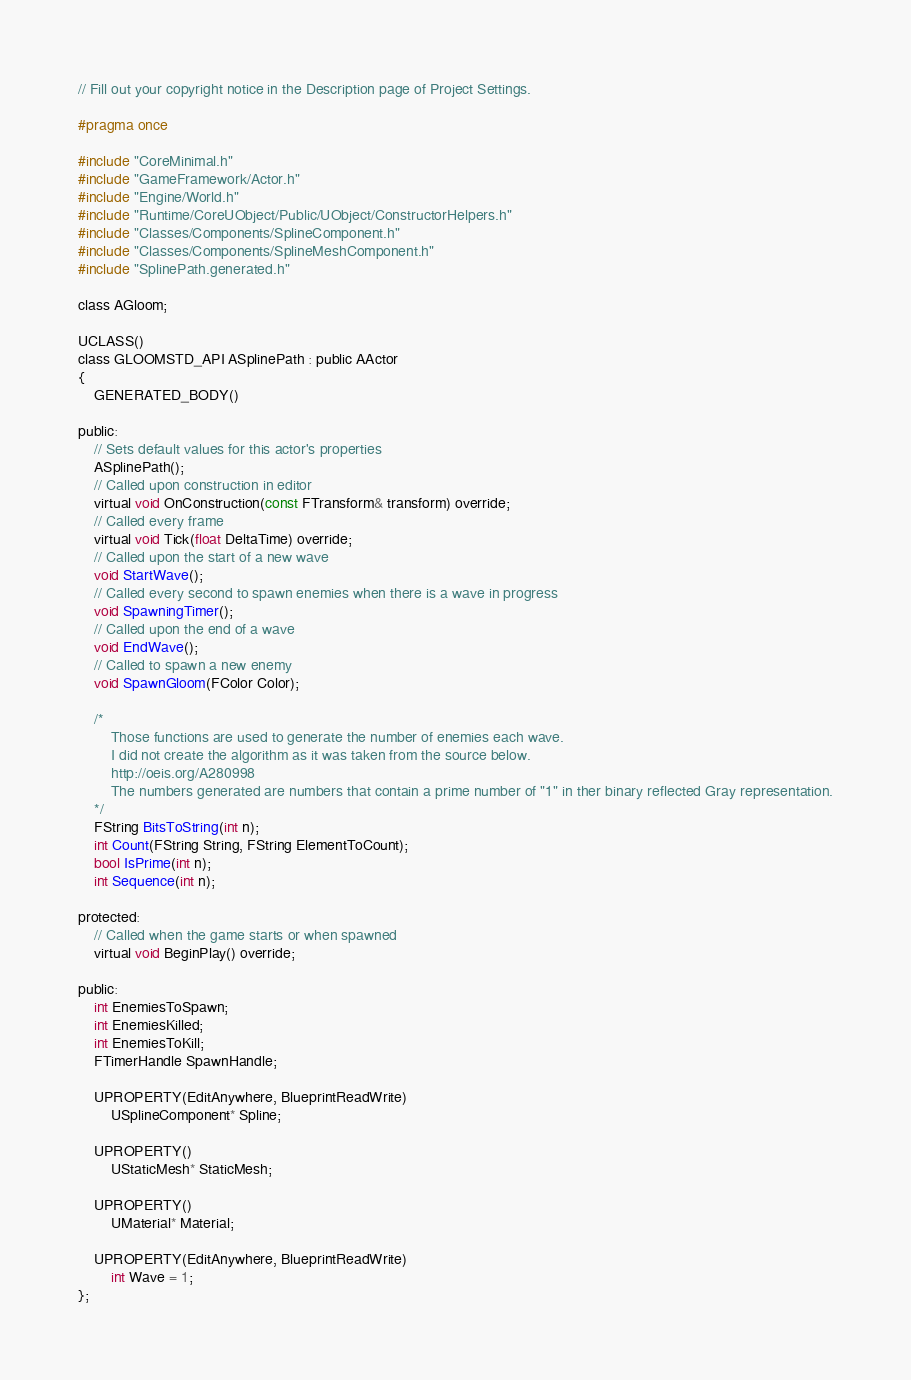<code> <loc_0><loc_0><loc_500><loc_500><_C_>// Fill out your copyright notice in the Description page of Project Settings.

#pragma once

#include "CoreMinimal.h"
#include "GameFramework/Actor.h"
#include "Engine/World.h"
#include "Runtime/CoreUObject/Public/UObject/ConstructorHelpers.h"
#include "Classes/Components/SplineComponent.h"
#include "Classes/Components/SplineMeshComponent.h"
#include "SplinePath.generated.h"

class AGloom;

UCLASS()
class GLOOMSTD_API ASplinePath : public AActor
{
	GENERATED_BODY()
	
public:	
	// Sets default values for this actor's properties
	ASplinePath();
	// Called upon construction in editor
	virtual void OnConstruction(const FTransform& transform) override;
	// Called every frame
	virtual void Tick(float DeltaTime) override;
	// Called upon the start of a new wave
	void StartWave();
	// Called every second to spawn enemies when there is a wave in progress
	void SpawningTimer();
	// Called upon the end of a wave
	void EndWave();
	// Called to spawn a new enemy
	void SpawnGloom(FColor Color);

	/*
		Those functions are used to generate the number of enemies each wave. 
		I did not create the algorithm as it was taken from the source below.
		http://oeis.org/A280998
		The numbers generated are numbers that contain a prime number of "1" in ther binary reflected Gray representation.
	*/
	FString BitsToString(int n);
	int Count(FString String, FString ElementToCount);
	bool IsPrime(int n);
	int Sequence(int n);

protected:
	// Called when the game starts or when spawned
	virtual void BeginPlay() override;

public:	
	int EnemiesToSpawn;
	int EnemiesKilled;	
	int EnemiesToKill;
	FTimerHandle SpawnHandle;

	UPROPERTY(EditAnywhere, BlueprintReadWrite)
		USplineComponent* Spline;

	UPROPERTY()
		UStaticMesh* StaticMesh;

	UPROPERTY()
		UMaterial* Material;

	UPROPERTY(EditAnywhere, BlueprintReadWrite)
		int Wave = 1;
};</code> 